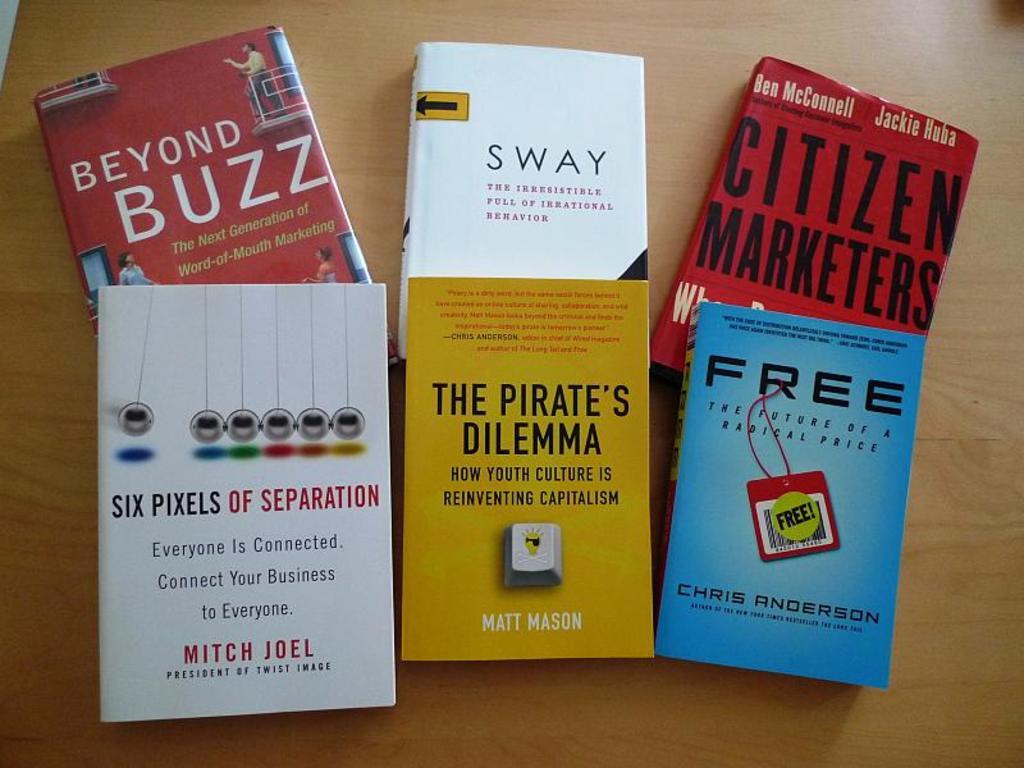Who wrote the yellow book?
Offer a terse response. Matt mason. What is the title of the middle white book?
Your answer should be very brief. Sway. 